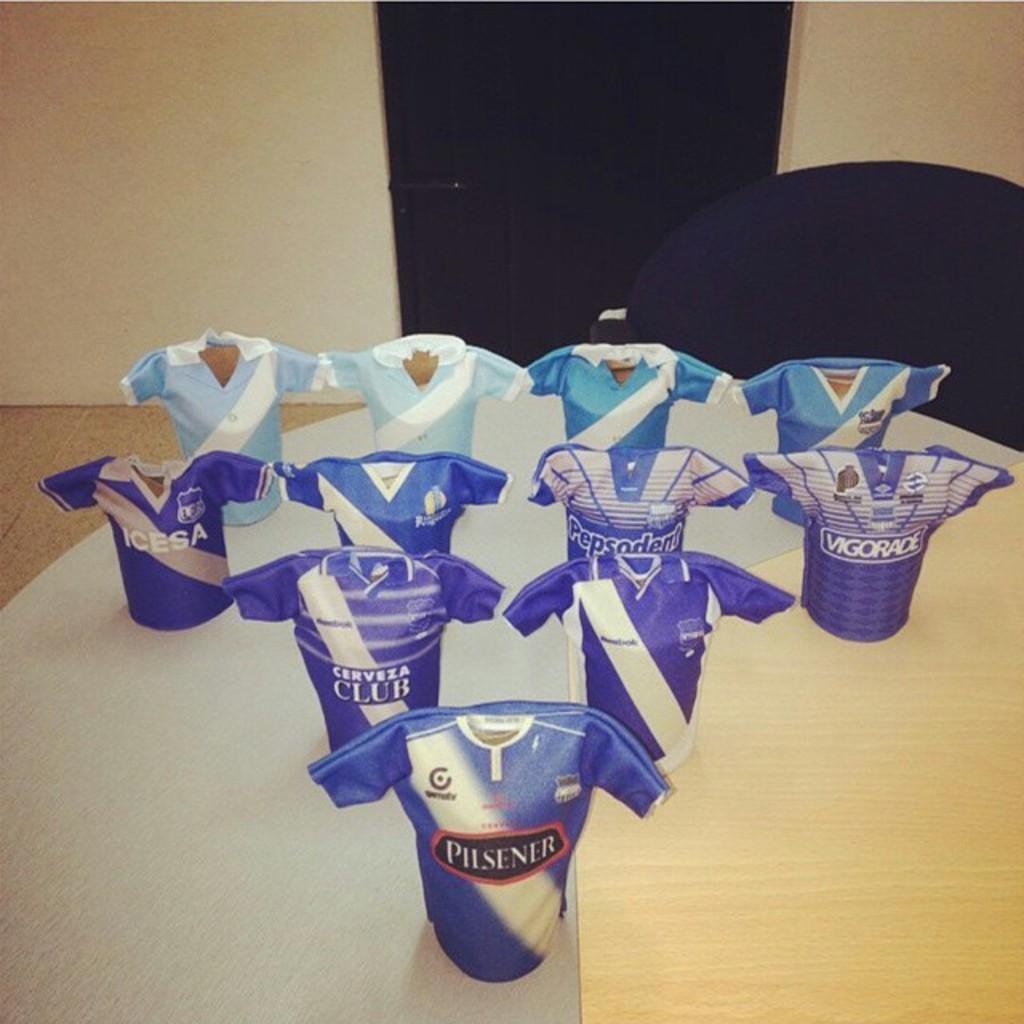Who is the sponsor of the closest object?
Give a very brief answer. Pilsener. 